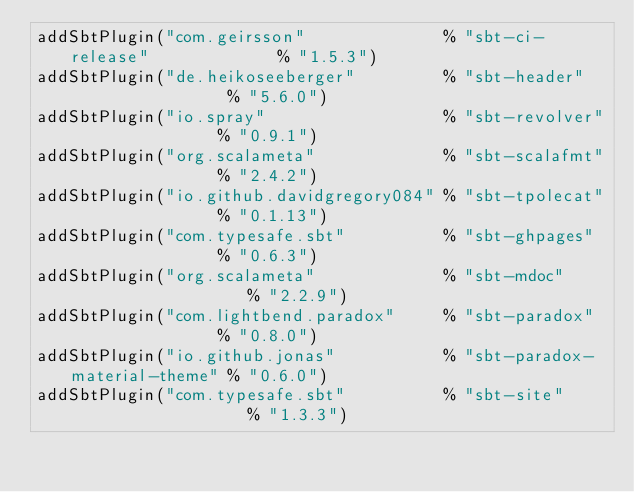Convert code to text. <code><loc_0><loc_0><loc_500><loc_500><_Scala_>addSbtPlugin("com.geirsson"              % "sbt-ci-release"             % "1.5.3")
addSbtPlugin("de.heikoseeberger"         % "sbt-header"                 % "5.6.0")
addSbtPlugin("io.spray"                  % "sbt-revolver"               % "0.9.1")
addSbtPlugin("org.scalameta"             % "sbt-scalafmt"               % "2.4.2")
addSbtPlugin("io.github.davidgregory084" % "sbt-tpolecat"               % "0.1.13")
addSbtPlugin("com.typesafe.sbt"          % "sbt-ghpages"                % "0.6.3")
addSbtPlugin("org.scalameta"             % "sbt-mdoc"                   % "2.2.9")
addSbtPlugin("com.lightbend.paradox"     % "sbt-paradox"                % "0.8.0")
addSbtPlugin("io.github.jonas"           % "sbt-paradox-material-theme" % "0.6.0")
addSbtPlugin("com.typesafe.sbt"          % "sbt-site"                   % "1.3.3")
</code> 